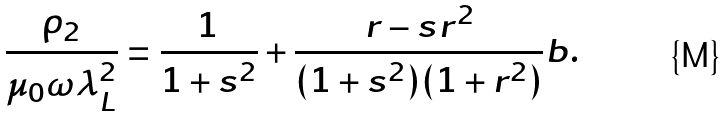Convert formula to latex. <formula><loc_0><loc_0><loc_500><loc_500>\frac { \rho _ { 2 } } { \mu _ { 0 } \omega \lambda _ { L } ^ { 2 } } = \frac { 1 } { 1 + s ^ { 2 } } + \frac { r - s r ^ { 2 } } { ( 1 + s ^ { 2 } ) ( 1 + r ^ { 2 } ) } b .</formula> 